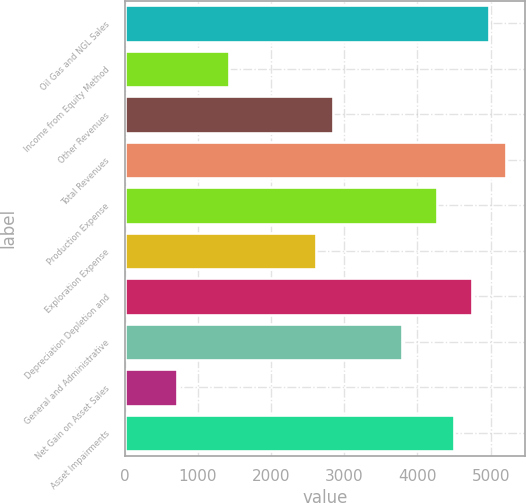<chart> <loc_0><loc_0><loc_500><loc_500><bar_chart><fcel>Oil Gas and NGL Sales<fcel>Income from Equity Method<fcel>Other Revenues<fcel>Total Revenues<fcel>Production Expense<fcel>Exploration Expense<fcel>Depreciation Depletion and<fcel>General and Administrative<fcel>Net Gain on Asset Sales<fcel>Asset Impairments<nl><fcel>4978.28<fcel>1422.92<fcel>2845.1<fcel>5215.3<fcel>4267.22<fcel>2608.07<fcel>4741.26<fcel>3793.18<fcel>711.84<fcel>4504.24<nl></chart> 